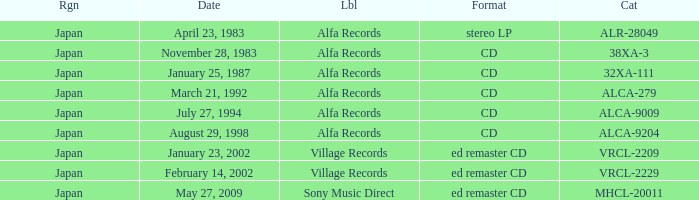Which label is dated February 14, 2002? Village Records. 